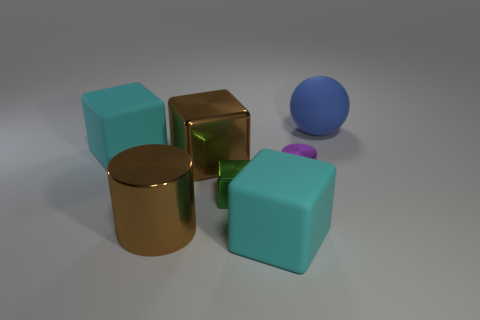Are there any tiny metal things behind the rubber sphere?
Offer a very short reply. No. How many other small purple matte objects have the same shape as the purple thing?
Your answer should be very brief. 0. The large matte object that is to the right of the matte block that is in front of the cyan matte thing that is behind the large brown cube is what color?
Make the answer very short. Blue. Is the material of the big brown object behind the small cylinder the same as the cyan block that is on the right side of the large metal cylinder?
Your response must be concise. No. How many things are matte cubes in front of the purple object or large brown shiny blocks?
Your response must be concise. 2. How many objects are small cylinders or large objects that are on the left side of the blue thing?
Your answer should be compact. 5. What number of metallic blocks are the same size as the purple thing?
Keep it short and to the point. 1. Is the number of big cyan matte things in front of the brown cylinder less than the number of green things on the left side of the green block?
Make the answer very short. No. What number of rubber things are brown blocks or big objects?
Make the answer very short. 3. There is a small purple object; what shape is it?
Your answer should be compact. Cylinder. 